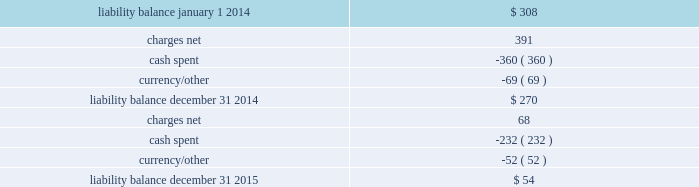Movement in exit cost liabilities the movement in exit cost liabilities for pmi was as follows : ( in millions ) .
Cash payments related to exit costs at pmi were $ 232 million , $ 360 million and $ 21 million for the years ended december 31 , 2015 , 2014 and 2013 , respectively .
Future cash payments for exit costs incurred to date are expected to be approximately $ 54 million , and will be substantially paid by the end of 2017 .
The pre-tax asset impairment and exit costs shown above are primarily a result of the following : the netherlands on april 4 , 2014 , pmi announced the initiation by its affiliate , philip morris holland b.v .
( 201cpmh 201d ) , of consultations with employee representatives on a proposal to discontinue cigarette production at its factory located in bergen op zoom , the netherlands .
Pmh reached an agreement with the trade unions and their members on a social plan and ceased cigarette production on september 1 , 2014 .
During 2014 , total pre-tax asset impairment and exit costs of $ 489 million were recorded for this program in the european union segment .
This amount includes employee separation costs of $ 343 million , asset impairment costs of $ 139 million and other separation costs of $ 7 million .
Separation program charges pmi recorded other pre-tax separation program charges of $ 68 million , $ 41 million and $ 51 million for the years ended december 31 , 2015 , 2014 and 2013 , respectively .
The 2015 other pre-tax separation program charges primarily related to severance costs for the organizational restructuring in the european union segment .
The 2014 other pre-tax separation program charges primarily related to severance costs for factory closures in australia and canada and the restructuring of the u.s .
Leaf purchasing model .
The 2013 pre-tax separation program charges primarily related to the restructuring of global and regional functions based in switzerland and australia .
Contract termination charges during 2013 , pmi recorded exit costs of $ 258 million related to the termination of distribution agreements in eastern europe , middle east & africa ( due to a new business model in egypt ) and asia .
Asset impairment charges during 2014 , pmi recorded other pre-tax asset impairment charges of $ 5 million related to a factory closure in canada. .
What was the difference in cash payments related to exit costs at pmi from 2014 to 2015 in millions? 
Computations: (232 - 360)
Answer: -128.0. 